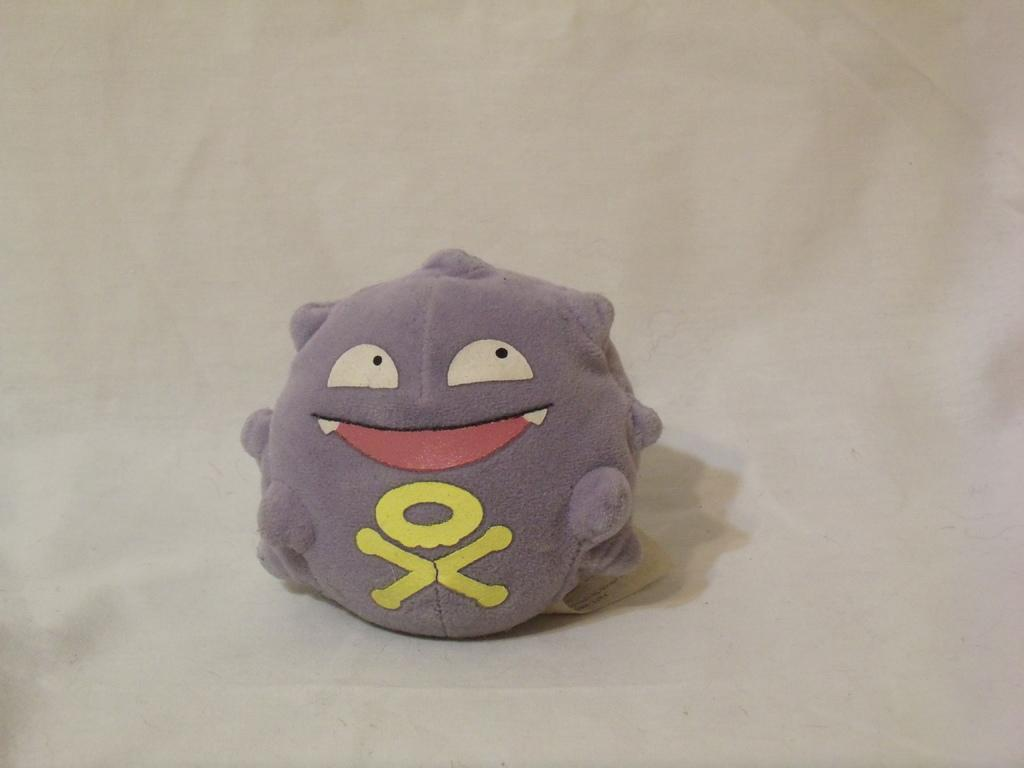What type of object is in the image? There is a stuffed toy in the image. Where is the stuffed toy located? The stuffed toy is placed on a surface. What type of screw can be seen holding the stuffed toy together in the image? There is no screw visible in the image, as it features a stuffed toy placed on a surface. 